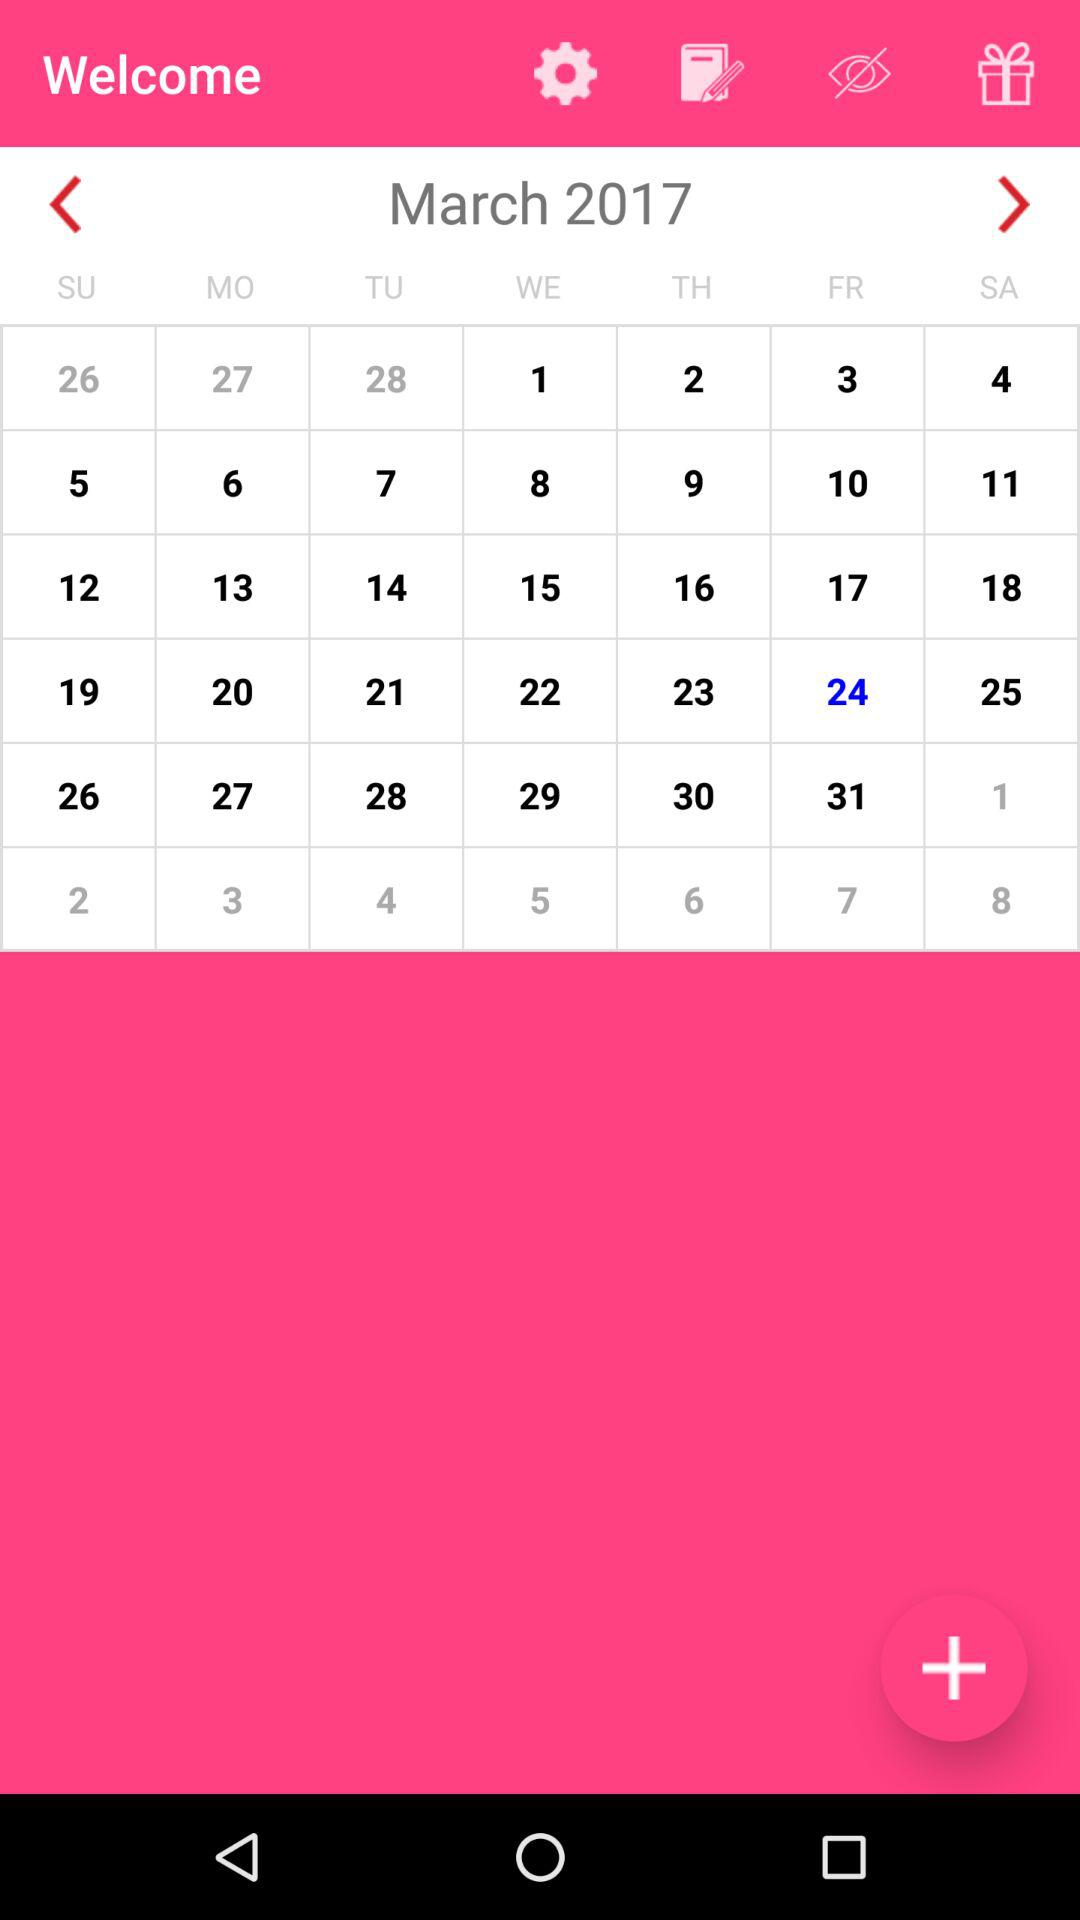What day is on the selected date? The day is Friday. 